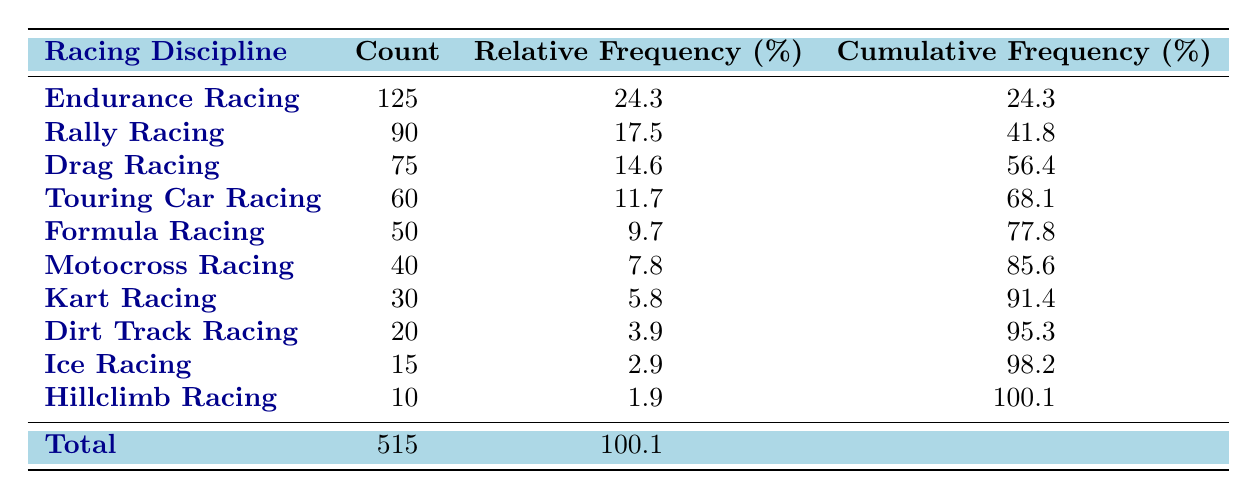What is the count of Endurance Racing? The table lists the count of Endurance Racing directly as 125. Therefore, this is a retrieval question that can be answered by simply referring to the table.
Answer: 125 Which racing discipline has the lowest count? According to the table, Hillclimb Racing has the lowest count at 10, as compared to all other disciplines listed. This is another retrieval question.
Answer: Hillclimb Racing What is the total count of all racing disciplines? The table includes a total count row at the bottom which indicates that the overall total is 515. Thus, this question is straightforward to answer.
Answer: 515 What is the relative frequency of Drag Racing in percentage? The relative frequency for Drag Racing is explicitly given in the table as 14.6%. This is a direct retrieval from the table data.
Answer: 14.6% What is the difference between the counts of Rally Racing and Ice Racing? The count for Rally Racing is 90, and for Ice Racing, it is 15. To find the difference, subtract 15 from 90, giving 75. This requires a simple mathematical operation.
Answer: 75 Is the count of Motocross Racing greater than the total count of Dirt Track Racing and Ice Racing combined? The count of Motocross Racing is 40, while the combined total of Dirt Track Racing (20) and Ice Racing (15) is 35. Since 40 is greater than 35, the answer is yes. This is a fact-based question requiring comparison.
Answer: Yes Which racing disciplines combined have a count greater than 200? Adding the counts of Endurance Racing (125) and Rally Racing (90) gives 215, which is greater than 200. However, adding in Drag Racing (75), which along with Rally Racing alone already meets this requirement, implies it could be different combinations. The answer involves checking various combinations before concluding.
Answer: Yes What is the cumulative frequency of Touring Car Racing? The cumulative frequency of Touring Car Racing is presented in the table as 68.1%. This number indicates the total percentage of categories up to and including Touring Car Racing.
Answer: 68.1% If you combine the counts of Kart Racing and Dirt Track Racing, will it be less than 60? The counts of Kart Racing (30) and Dirt Track Racing (20) combine to make 50, which is indeed less than 60. This involves simple addition followed by a comparison.
Answer: Yes 